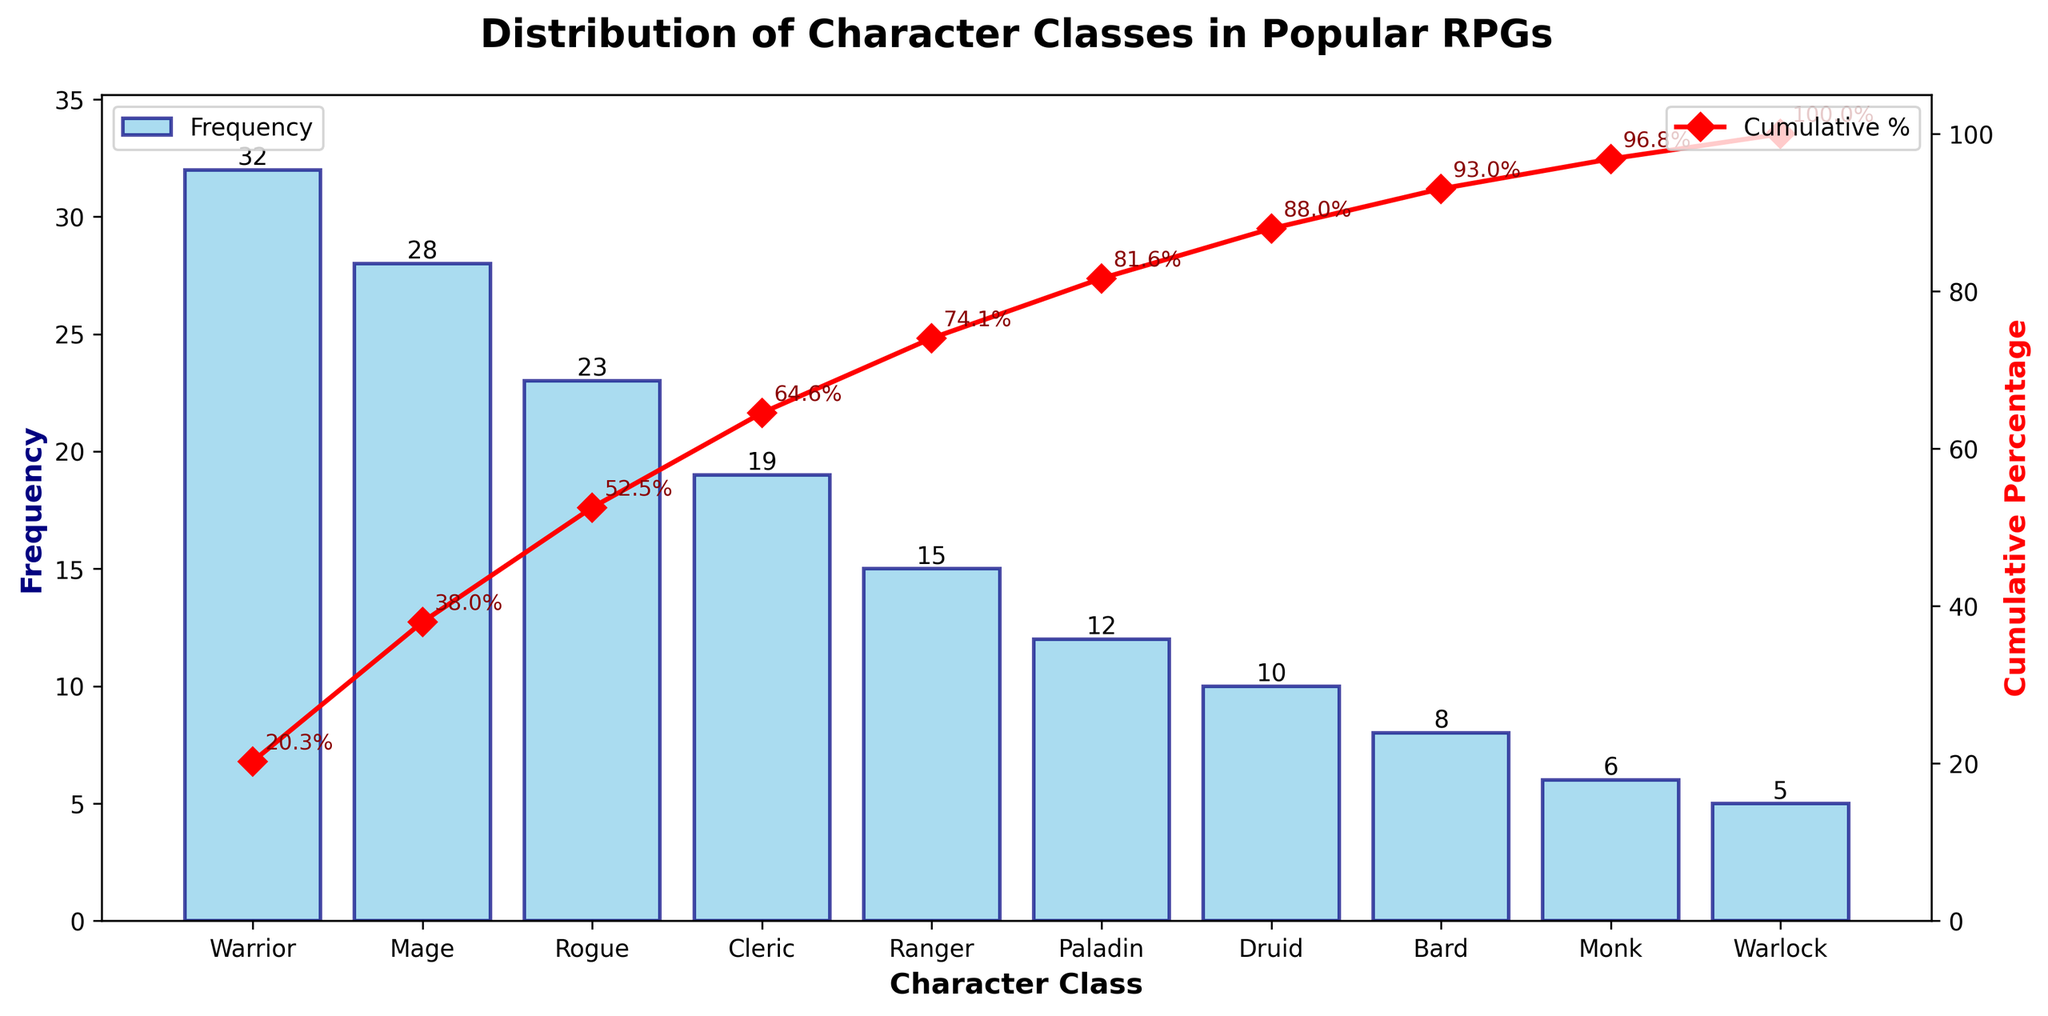What's the title of the figure? The title is located at the top center of the figure. It typically describes the main subject of the figure.
Answer: Distribution of Character Classes in Popular RPGs What is the character class with the highest frequency? By looking at the height of the bars, the tallest bar represents the highest frequency character class.
Answer: Warrior How many character classes have a frequency greater than or equal to 20? Identify bars with a height of 20 or more, counting those bars.
Answer: 4 What is the cumulative percentage for the Rogue character class? Locate the Rogue on the x-axis and find its corresponding line plot value in percentage.
Answer: ~70.3% Which character class has a frequency less than Monk but more than Warlock? Compare the heights of the bars for Monk and Warlock and find the bar that fits in between these two frequencies.
Answer: Bard What is the total frequency of Warrior and Mage combined? Add the frequencies of Warrior and Mage: 32 (Warrior) + 28 (Mage).
Answer: 60 What is the cumulative percentage after adding the Druid frequency? Find the cumulative percentage value at Druid on the x-axis.
Answer: ~93.2% By how much does the Warrior's frequency exceed the Paladin's? Subtract the Paladin's frequency from the Warrior's: 32 - 12.
Answer: 20 Which character class follows Ranger in terms of frequency ranking? Locate and understand the order on the x-axis; see which class is immediately after Ranger.
Answer: Paladin What color and shape are used for marking the cumulative percentage line? Refer to the visual properties of the line representing cumulative percentage in the figure.
Answer: Red with diamond markers 